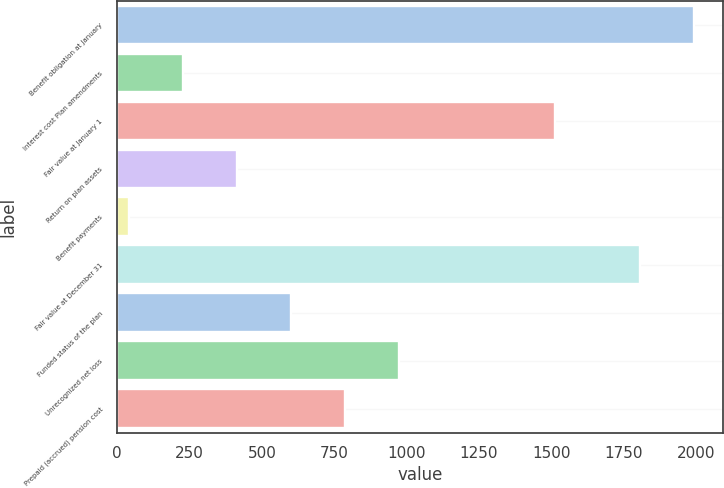<chart> <loc_0><loc_0><loc_500><loc_500><bar_chart><fcel>Benefit obligation at January<fcel>Interest cost Plan amendments<fcel>Fair value at January 1<fcel>Return on plan assets<fcel>Benefit payments<fcel>Fair value at December 31<fcel>Funded status of the plan<fcel>Unrecognized net loss<fcel>Prepaid (accrued) pension cost<nl><fcel>1992.3<fcel>227.3<fcel>1513<fcel>413.6<fcel>41<fcel>1806<fcel>599.9<fcel>972.5<fcel>786.2<nl></chart> 